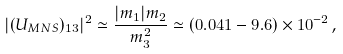Convert formula to latex. <formula><loc_0><loc_0><loc_500><loc_500>| ( U _ { M N S } ) _ { 1 3 } | ^ { 2 } \simeq \frac { | m _ { 1 } | m _ { 2 } } { m _ { 3 } ^ { 2 } } \simeq ( 0 . 0 4 1 - 9 . 6 ) \times 1 0 ^ { - 2 } \, ,</formula> 